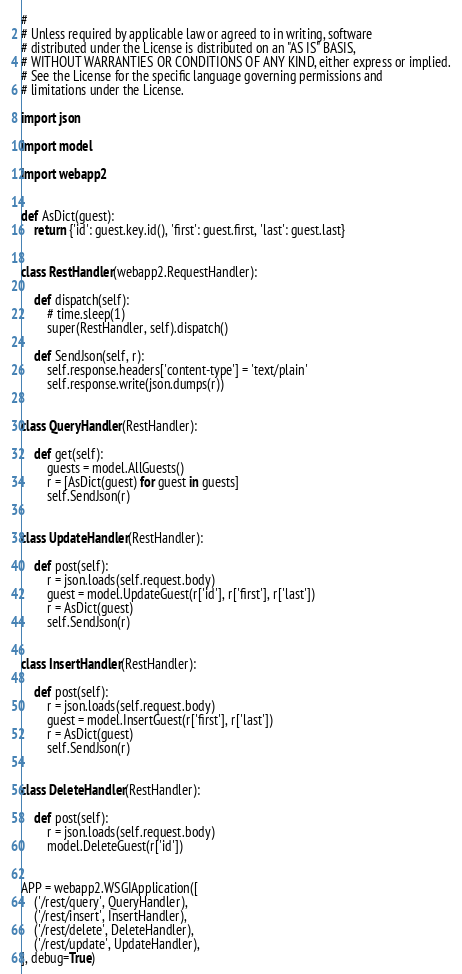<code> <loc_0><loc_0><loc_500><loc_500><_Python_>#
# Unless required by applicable law or agreed to in writing, software
# distributed under the License is distributed on an "AS IS" BASIS,
# WITHOUT WARRANTIES OR CONDITIONS OF ANY KIND, either express or implied.
# See the License for the specific language governing permissions and
# limitations under the License.

import json

import model

import webapp2


def AsDict(guest):
    return {'id': guest.key.id(), 'first': guest.first, 'last': guest.last}


class RestHandler(webapp2.RequestHandler):

    def dispatch(self):
        # time.sleep(1)
        super(RestHandler, self).dispatch()

    def SendJson(self, r):
        self.response.headers['content-type'] = 'text/plain'
        self.response.write(json.dumps(r))


class QueryHandler(RestHandler):

    def get(self):
        guests = model.AllGuests()
        r = [AsDict(guest) for guest in guests]
        self.SendJson(r)


class UpdateHandler(RestHandler):

    def post(self):
        r = json.loads(self.request.body)
        guest = model.UpdateGuest(r['id'], r['first'], r['last'])
        r = AsDict(guest)
        self.SendJson(r)


class InsertHandler(RestHandler):

    def post(self):
        r = json.loads(self.request.body)
        guest = model.InsertGuest(r['first'], r['last'])
        r = AsDict(guest)
        self.SendJson(r)


class DeleteHandler(RestHandler):

    def post(self):
        r = json.loads(self.request.body)
        model.DeleteGuest(r['id'])


APP = webapp2.WSGIApplication([
    ('/rest/query', QueryHandler),
    ('/rest/insert', InsertHandler),
    ('/rest/delete', DeleteHandler),
    ('/rest/update', UpdateHandler),
], debug=True)
</code> 